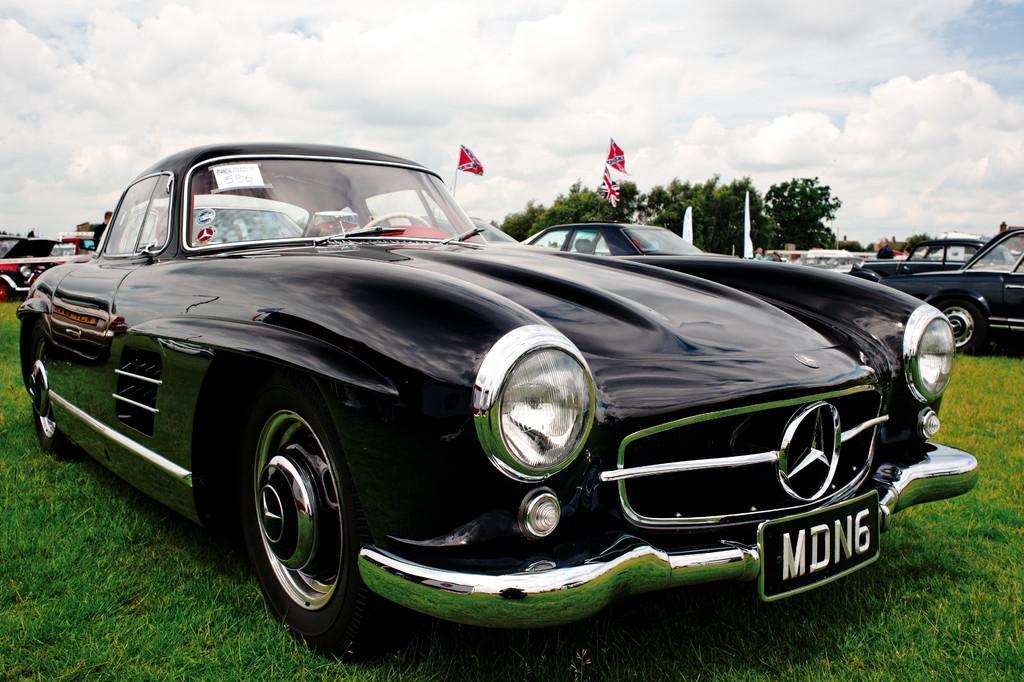Describe this image in one or two sentences. In this image we can see there are few cars parked on the surface of the grass. In the background there are few flags, trees and a sky. 